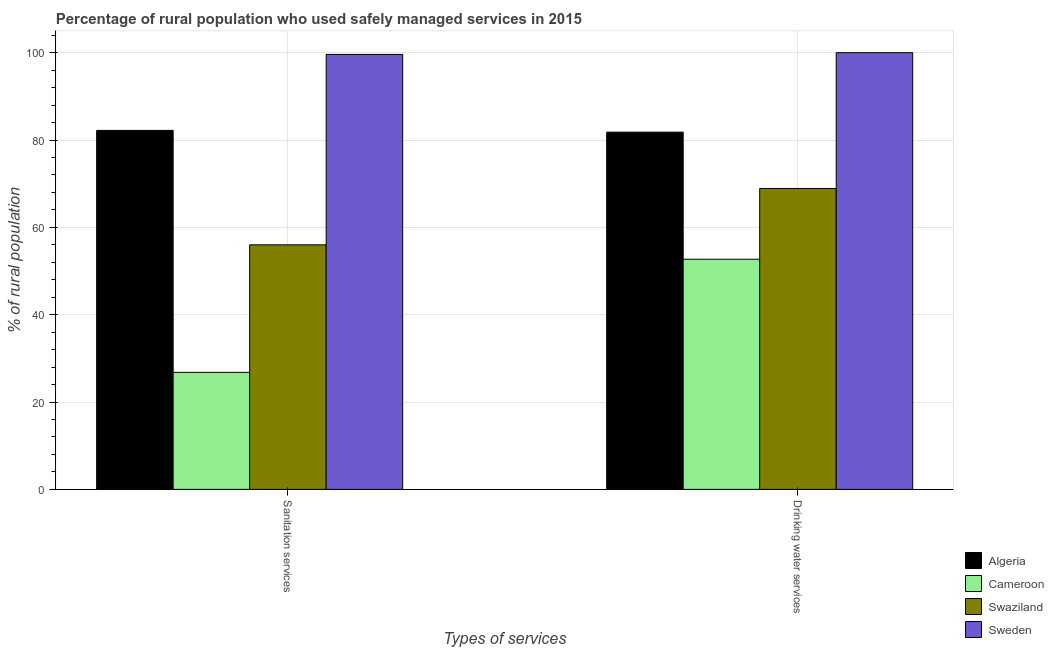How many different coloured bars are there?
Provide a succinct answer. 4. How many groups of bars are there?
Keep it short and to the point. 2. What is the label of the 1st group of bars from the left?
Ensure brevity in your answer.  Sanitation services. What is the percentage of rural population who used sanitation services in Algeria?
Your answer should be very brief. 82.2. Across all countries, what is the maximum percentage of rural population who used sanitation services?
Offer a terse response. 99.6. Across all countries, what is the minimum percentage of rural population who used drinking water services?
Provide a short and direct response. 52.7. In which country was the percentage of rural population who used sanitation services maximum?
Keep it short and to the point. Sweden. In which country was the percentage of rural population who used drinking water services minimum?
Ensure brevity in your answer.  Cameroon. What is the total percentage of rural population who used drinking water services in the graph?
Make the answer very short. 303.4. What is the difference between the percentage of rural population who used drinking water services in Cameroon and that in Algeria?
Keep it short and to the point. -29.1. What is the difference between the percentage of rural population who used sanitation services in Cameroon and the percentage of rural population who used drinking water services in Algeria?
Offer a terse response. -55. What is the average percentage of rural population who used drinking water services per country?
Provide a short and direct response. 75.85. What is the difference between the percentage of rural population who used sanitation services and percentage of rural population who used drinking water services in Swaziland?
Keep it short and to the point. -12.9. What is the ratio of the percentage of rural population who used drinking water services in Algeria to that in Swaziland?
Your response must be concise. 1.19. Is the percentage of rural population who used sanitation services in Sweden less than that in Swaziland?
Ensure brevity in your answer.  No. What does the 2nd bar from the left in Sanitation services represents?
Provide a succinct answer. Cameroon. What does the 3rd bar from the right in Drinking water services represents?
Provide a succinct answer. Cameroon. How many bars are there?
Your answer should be very brief. 8. Are all the bars in the graph horizontal?
Offer a very short reply. No. Does the graph contain any zero values?
Offer a terse response. No. Does the graph contain grids?
Offer a very short reply. Yes. How many legend labels are there?
Your answer should be compact. 4. How are the legend labels stacked?
Ensure brevity in your answer.  Vertical. What is the title of the graph?
Ensure brevity in your answer.  Percentage of rural population who used safely managed services in 2015. Does "Benin" appear as one of the legend labels in the graph?
Your answer should be compact. No. What is the label or title of the X-axis?
Your answer should be compact. Types of services. What is the label or title of the Y-axis?
Your response must be concise. % of rural population. What is the % of rural population in Algeria in Sanitation services?
Your answer should be very brief. 82.2. What is the % of rural population in Cameroon in Sanitation services?
Ensure brevity in your answer.  26.8. What is the % of rural population in Swaziland in Sanitation services?
Your answer should be very brief. 56. What is the % of rural population of Sweden in Sanitation services?
Ensure brevity in your answer.  99.6. What is the % of rural population in Algeria in Drinking water services?
Provide a short and direct response. 81.8. What is the % of rural population of Cameroon in Drinking water services?
Give a very brief answer. 52.7. What is the % of rural population in Swaziland in Drinking water services?
Offer a very short reply. 68.9. What is the % of rural population of Sweden in Drinking water services?
Offer a very short reply. 100. Across all Types of services, what is the maximum % of rural population in Algeria?
Ensure brevity in your answer.  82.2. Across all Types of services, what is the maximum % of rural population in Cameroon?
Make the answer very short. 52.7. Across all Types of services, what is the maximum % of rural population in Swaziland?
Offer a very short reply. 68.9. Across all Types of services, what is the maximum % of rural population in Sweden?
Your answer should be very brief. 100. Across all Types of services, what is the minimum % of rural population of Algeria?
Your answer should be very brief. 81.8. Across all Types of services, what is the minimum % of rural population in Cameroon?
Offer a terse response. 26.8. Across all Types of services, what is the minimum % of rural population of Swaziland?
Provide a succinct answer. 56. Across all Types of services, what is the minimum % of rural population of Sweden?
Keep it short and to the point. 99.6. What is the total % of rural population in Algeria in the graph?
Offer a very short reply. 164. What is the total % of rural population in Cameroon in the graph?
Keep it short and to the point. 79.5. What is the total % of rural population of Swaziland in the graph?
Give a very brief answer. 124.9. What is the total % of rural population of Sweden in the graph?
Offer a terse response. 199.6. What is the difference between the % of rural population of Cameroon in Sanitation services and that in Drinking water services?
Keep it short and to the point. -25.9. What is the difference between the % of rural population of Swaziland in Sanitation services and that in Drinking water services?
Ensure brevity in your answer.  -12.9. What is the difference between the % of rural population in Sweden in Sanitation services and that in Drinking water services?
Give a very brief answer. -0.4. What is the difference between the % of rural population of Algeria in Sanitation services and the % of rural population of Cameroon in Drinking water services?
Offer a terse response. 29.5. What is the difference between the % of rural population in Algeria in Sanitation services and the % of rural population in Sweden in Drinking water services?
Ensure brevity in your answer.  -17.8. What is the difference between the % of rural population in Cameroon in Sanitation services and the % of rural population in Swaziland in Drinking water services?
Offer a terse response. -42.1. What is the difference between the % of rural population in Cameroon in Sanitation services and the % of rural population in Sweden in Drinking water services?
Your answer should be compact. -73.2. What is the difference between the % of rural population in Swaziland in Sanitation services and the % of rural population in Sweden in Drinking water services?
Give a very brief answer. -44. What is the average % of rural population in Algeria per Types of services?
Your response must be concise. 82. What is the average % of rural population of Cameroon per Types of services?
Provide a short and direct response. 39.75. What is the average % of rural population in Swaziland per Types of services?
Give a very brief answer. 62.45. What is the average % of rural population of Sweden per Types of services?
Keep it short and to the point. 99.8. What is the difference between the % of rural population in Algeria and % of rural population in Cameroon in Sanitation services?
Your response must be concise. 55.4. What is the difference between the % of rural population in Algeria and % of rural population in Swaziland in Sanitation services?
Your answer should be very brief. 26.2. What is the difference between the % of rural population in Algeria and % of rural population in Sweden in Sanitation services?
Ensure brevity in your answer.  -17.4. What is the difference between the % of rural population of Cameroon and % of rural population of Swaziland in Sanitation services?
Offer a very short reply. -29.2. What is the difference between the % of rural population of Cameroon and % of rural population of Sweden in Sanitation services?
Provide a succinct answer. -72.8. What is the difference between the % of rural population of Swaziland and % of rural population of Sweden in Sanitation services?
Ensure brevity in your answer.  -43.6. What is the difference between the % of rural population of Algeria and % of rural population of Cameroon in Drinking water services?
Offer a terse response. 29.1. What is the difference between the % of rural population of Algeria and % of rural population of Swaziland in Drinking water services?
Give a very brief answer. 12.9. What is the difference between the % of rural population of Algeria and % of rural population of Sweden in Drinking water services?
Keep it short and to the point. -18.2. What is the difference between the % of rural population in Cameroon and % of rural population in Swaziland in Drinking water services?
Make the answer very short. -16.2. What is the difference between the % of rural population in Cameroon and % of rural population in Sweden in Drinking water services?
Provide a short and direct response. -47.3. What is the difference between the % of rural population of Swaziland and % of rural population of Sweden in Drinking water services?
Keep it short and to the point. -31.1. What is the ratio of the % of rural population in Cameroon in Sanitation services to that in Drinking water services?
Keep it short and to the point. 0.51. What is the ratio of the % of rural population in Swaziland in Sanitation services to that in Drinking water services?
Your answer should be compact. 0.81. What is the difference between the highest and the second highest % of rural population of Cameroon?
Your answer should be very brief. 25.9. What is the difference between the highest and the second highest % of rural population in Swaziland?
Offer a very short reply. 12.9. What is the difference between the highest and the second highest % of rural population of Sweden?
Ensure brevity in your answer.  0.4. What is the difference between the highest and the lowest % of rural population in Algeria?
Give a very brief answer. 0.4. What is the difference between the highest and the lowest % of rural population in Cameroon?
Your answer should be very brief. 25.9. What is the difference between the highest and the lowest % of rural population in Swaziland?
Your response must be concise. 12.9. 